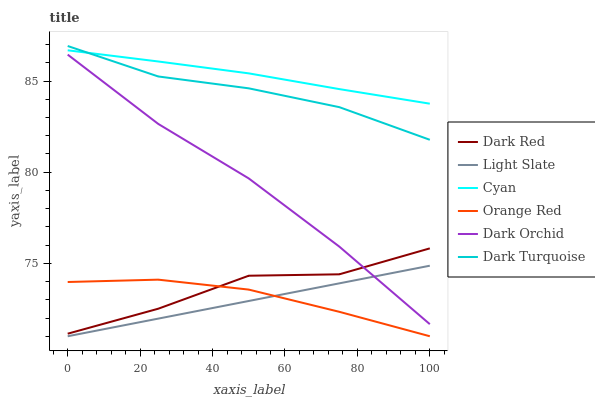Does Light Slate have the minimum area under the curve?
Answer yes or no. Yes. Does Cyan have the maximum area under the curve?
Answer yes or no. Yes. Does Dark Red have the minimum area under the curve?
Answer yes or no. No. Does Dark Red have the maximum area under the curve?
Answer yes or no. No. Is Light Slate the smoothest?
Answer yes or no. Yes. Is Dark Red the roughest?
Answer yes or no. Yes. Is Dark Orchid the smoothest?
Answer yes or no. No. Is Dark Orchid the roughest?
Answer yes or no. No. Does Light Slate have the lowest value?
Answer yes or no. Yes. Does Dark Red have the lowest value?
Answer yes or no. No. Does Dark Turquoise have the highest value?
Answer yes or no. Yes. Does Dark Red have the highest value?
Answer yes or no. No. Is Orange Red less than Dark Turquoise?
Answer yes or no. Yes. Is Cyan greater than Dark Red?
Answer yes or no. Yes. Does Dark Orchid intersect Light Slate?
Answer yes or no. Yes. Is Dark Orchid less than Light Slate?
Answer yes or no. No. Is Dark Orchid greater than Light Slate?
Answer yes or no. No. Does Orange Red intersect Dark Turquoise?
Answer yes or no. No. 